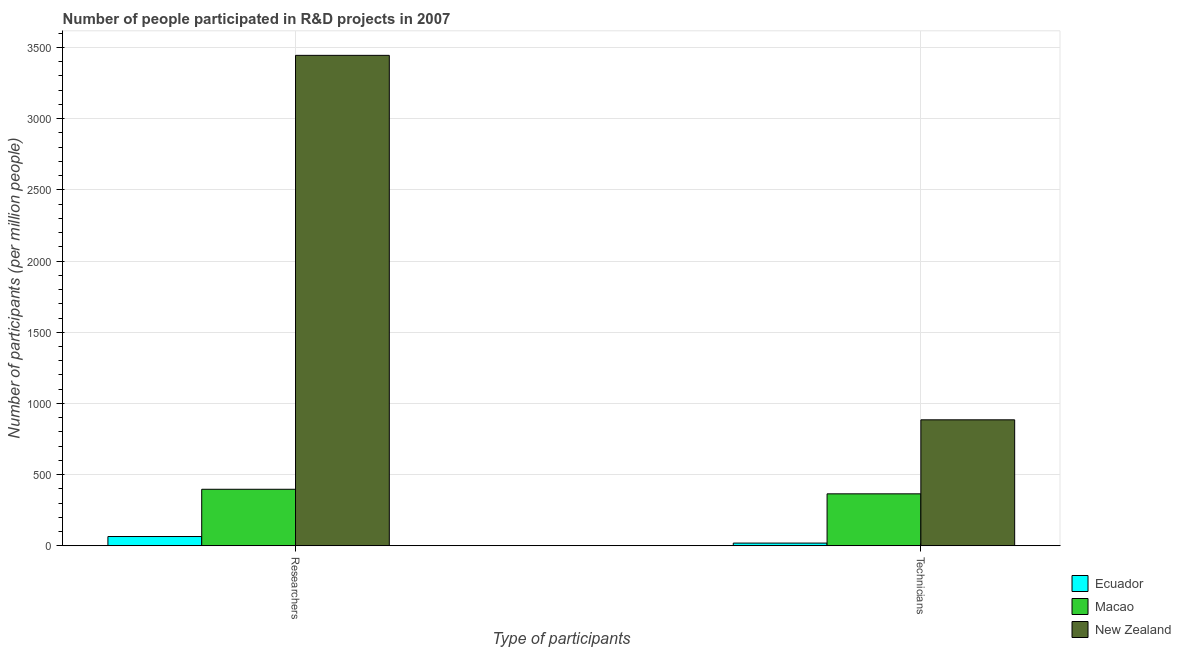How many groups of bars are there?
Offer a terse response. 2. How many bars are there on the 2nd tick from the left?
Give a very brief answer. 3. How many bars are there on the 2nd tick from the right?
Make the answer very short. 3. What is the label of the 1st group of bars from the left?
Provide a succinct answer. Researchers. What is the number of technicians in Macao?
Give a very brief answer. 364.89. Across all countries, what is the maximum number of technicians?
Your answer should be compact. 884.85. Across all countries, what is the minimum number of researchers?
Keep it short and to the point. 65.05. In which country was the number of technicians maximum?
Provide a short and direct response. New Zealand. In which country was the number of researchers minimum?
Your response must be concise. Ecuador. What is the total number of researchers in the graph?
Offer a very short reply. 3906.99. What is the difference between the number of technicians in Ecuador and that in New Zealand?
Give a very brief answer. -865.91. What is the difference between the number of researchers in Ecuador and the number of technicians in New Zealand?
Provide a succinct answer. -819.8. What is the average number of technicians per country?
Your answer should be compact. 422.89. What is the difference between the number of researchers and number of technicians in Macao?
Offer a very short reply. 32.05. What is the ratio of the number of researchers in Macao to that in Ecuador?
Your response must be concise. 6.1. What does the 1st bar from the left in Technicians represents?
Your answer should be compact. Ecuador. What does the 2nd bar from the right in Researchers represents?
Keep it short and to the point. Macao. How many countries are there in the graph?
Your response must be concise. 3. What is the difference between two consecutive major ticks on the Y-axis?
Your answer should be very brief. 500. Does the graph contain grids?
Your response must be concise. Yes. How many legend labels are there?
Give a very brief answer. 3. How are the legend labels stacked?
Your answer should be very brief. Vertical. What is the title of the graph?
Your answer should be compact. Number of people participated in R&D projects in 2007. Does "Ecuador" appear as one of the legend labels in the graph?
Your response must be concise. Yes. What is the label or title of the X-axis?
Your answer should be very brief. Type of participants. What is the label or title of the Y-axis?
Give a very brief answer. Number of participants (per million people). What is the Number of participants (per million people) of Ecuador in Researchers?
Give a very brief answer. 65.05. What is the Number of participants (per million people) of Macao in Researchers?
Provide a succinct answer. 396.94. What is the Number of participants (per million people) in New Zealand in Researchers?
Provide a short and direct response. 3445. What is the Number of participants (per million people) in Ecuador in Technicians?
Give a very brief answer. 18.94. What is the Number of participants (per million people) in Macao in Technicians?
Ensure brevity in your answer.  364.89. What is the Number of participants (per million people) in New Zealand in Technicians?
Provide a short and direct response. 884.85. Across all Type of participants, what is the maximum Number of participants (per million people) in Ecuador?
Ensure brevity in your answer.  65.05. Across all Type of participants, what is the maximum Number of participants (per million people) of Macao?
Your response must be concise. 396.94. Across all Type of participants, what is the maximum Number of participants (per million people) of New Zealand?
Your answer should be very brief. 3445. Across all Type of participants, what is the minimum Number of participants (per million people) in Ecuador?
Keep it short and to the point. 18.94. Across all Type of participants, what is the minimum Number of participants (per million people) in Macao?
Keep it short and to the point. 364.89. Across all Type of participants, what is the minimum Number of participants (per million people) in New Zealand?
Offer a very short reply. 884.85. What is the total Number of participants (per million people) in Ecuador in the graph?
Make the answer very short. 83.98. What is the total Number of participants (per million people) of Macao in the graph?
Your answer should be very brief. 761.83. What is the total Number of participants (per million people) in New Zealand in the graph?
Provide a succinct answer. 4329.85. What is the difference between the Number of participants (per million people) in Ecuador in Researchers and that in Technicians?
Give a very brief answer. 46.11. What is the difference between the Number of participants (per million people) in Macao in Researchers and that in Technicians?
Ensure brevity in your answer.  32.05. What is the difference between the Number of participants (per million people) of New Zealand in Researchers and that in Technicians?
Give a very brief answer. 2560.16. What is the difference between the Number of participants (per million people) in Ecuador in Researchers and the Number of participants (per million people) in Macao in Technicians?
Your response must be concise. -299.85. What is the difference between the Number of participants (per million people) in Ecuador in Researchers and the Number of participants (per million people) in New Zealand in Technicians?
Provide a succinct answer. -819.8. What is the difference between the Number of participants (per million people) in Macao in Researchers and the Number of participants (per million people) in New Zealand in Technicians?
Make the answer very short. -487.91. What is the average Number of participants (per million people) of Ecuador per Type of participants?
Ensure brevity in your answer.  41.99. What is the average Number of participants (per million people) of Macao per Type of participants?
Make the answer very short. 380.92. What is the average Number of participants (per million people) of New Zealand per Type of participants?
Make the answer very short. 2164.93. What is the difference between the Number of participants (per million people) of Ecuador and Number of participants (per million people) of Macao in Researchers?
Provide a succinct answer. -331.89. What is the difference between the Number of participants (per million people) of Ecuador and Number of participants (per million people) of New Zealand in Researchers?
Provide a succinct answer. -3379.96. What is the difference between the Number of participants (per million people) of Macao and Number of participants (per million people) of New Zealand in Researchers?
Keep it short and to the point. -3048.06. What is the difference between the Number of participants (per million people) in Ecuador and Number of participants (per million people) in Macao in Technicians?
Give a very brief answer. -345.96. What is the difference between the Number of participants (per million people) of Ecuador and Number of participants (per million people) of New Zealand in Technicians?
Your response must be concise. -865.91. What is the difference between the Number of participants (per million people) of Macao and Number of participants (per million people) of New Zealand in Technicians?
Ensure brevity in your answer.  -519.95. What is the ratio of the Number of participants (per million people) in Ecuador in Researchers to that in Technicians?
Your answer should be very brief. 3.43. What is the ratio of the Number of participants (per million people) in Macao in Researchers to that in Technicians?
Provide a short and direct response. 1.09. What is the ratio of the Number of participants (per million people) of New Zealand in Researchers to that in Technicians?
Offer a terse response. 3.89. What is the difference between the highest and the second highest Number of participants (per million people) of Ecuador?
Provide a succinct answer. 46.11. What is the difference between the highest and the second highest Number of participants (per million people) in Macao?
Provide a short and direct response. 32.05. What is the difference between the highest and the second highest Number of participants (per million people) in New Zealand?
Make the answer very short. 2560.16. What is the difference between the highest and the lowest Number of participants (per million people) in Ecuador?
Offer a terse response. 46.11. What is the difference between the highest and the lowest Number of participants (per million people) in Macao?
Provide a short and direct response. 32.05. What is the difference between the highest and the lowest Number of participants (per million people) of New Zealand?
Offer a very short reply. 2560.16. 